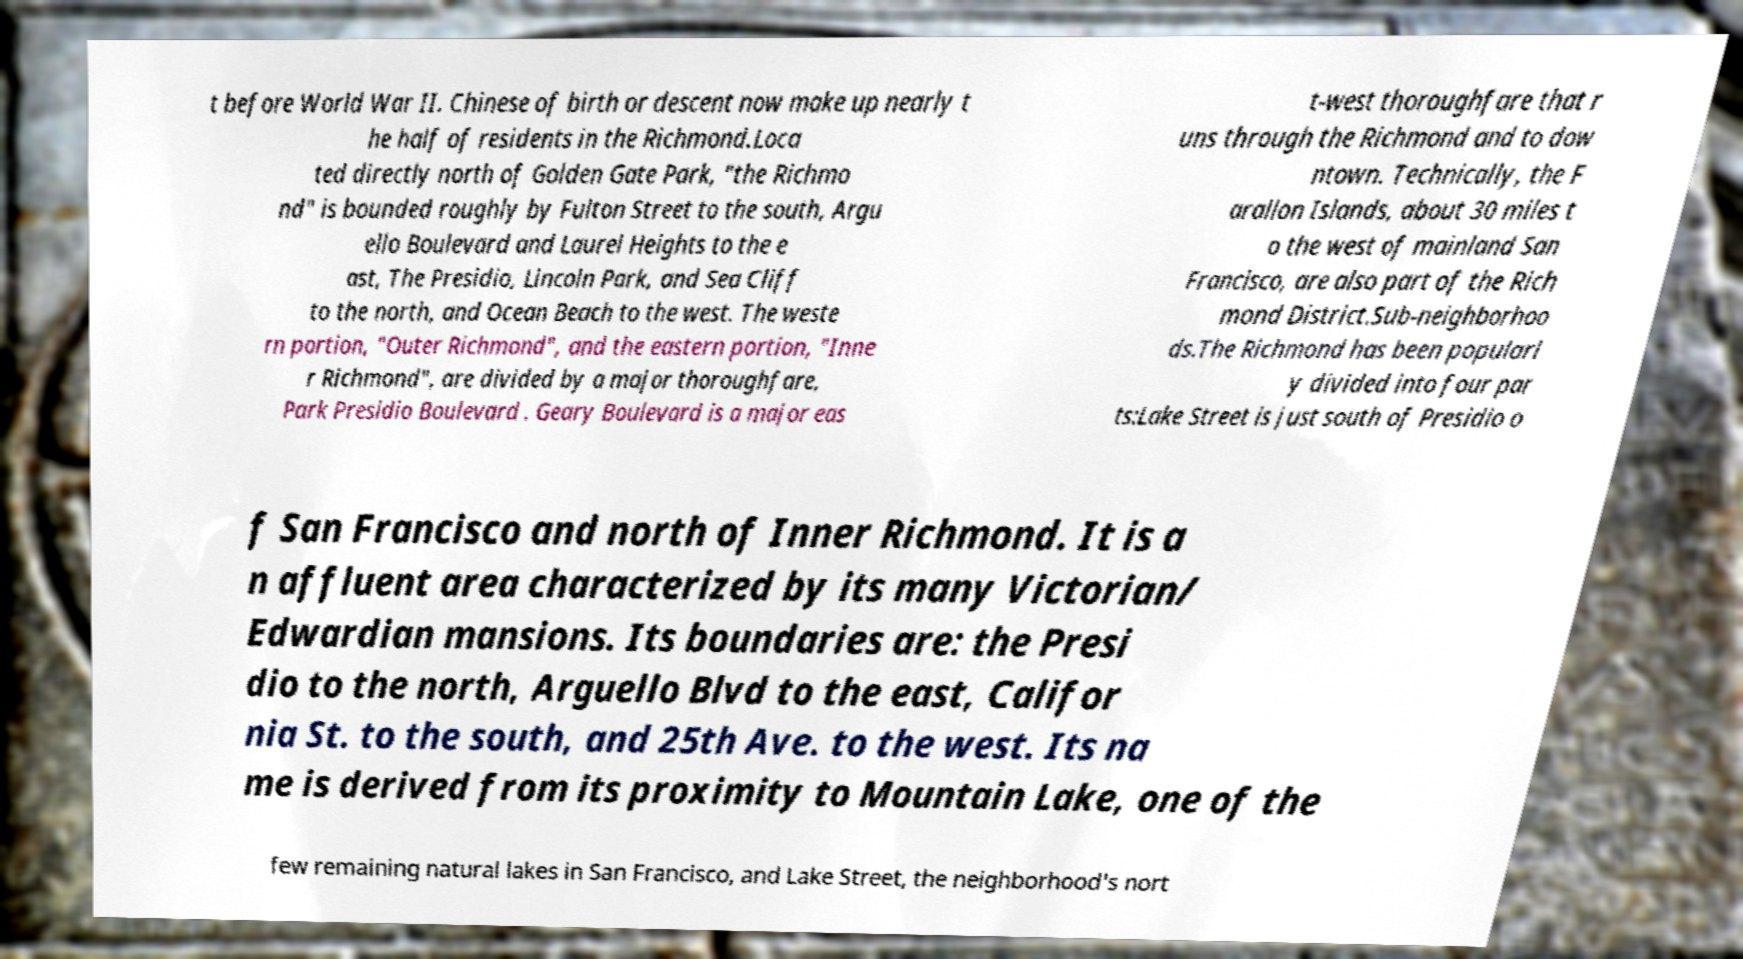Could you extract and type out the text from this image? t before World War II. Chinese of birth or descent now make up nearly t he half of residents in the Richmond.Loca ted directly north of Golden Gate Park, "the Richmo nd" is bounded roughly by Fulton Street to the south, Argu ello Boulevard and Laurel Heights to the e ast, The Presidio, Lincoln Park, and Sea Cliff to the north, and Ocean Beach to the west. The weste rn portion, "Outer Richmond", and the eastern portion, "Inne r Richmond", are divided by a major thoroughfare, Park Presidio Boulevard . Geary Boulevard is a major eas t-west thoroughfare that r uns through the Richmond and to dow ntown. Technically, the F arallon Islands, about 30 miles t o the west of mainland San Francisco, are also part of the Rich mond District.Sub-neighborhoo ds.The Richmond has been popularl y divided into four par ts:Lake Street is just south of Presidio o f San Francisco and north of Inner Richmond. It is a n affluent area characterized by its many Victorian/ Edwardian mansions. Its boundaries are: the Presi dio to the north, Arguello Blvd to the east, Califor nia St. to the south, and 25th Ave. to the west. Its na me is derived from its proximity to Mountain Lake, one of the few remaining natural lakes in San Francisco, and Lake Street, the neighborhood's nort 